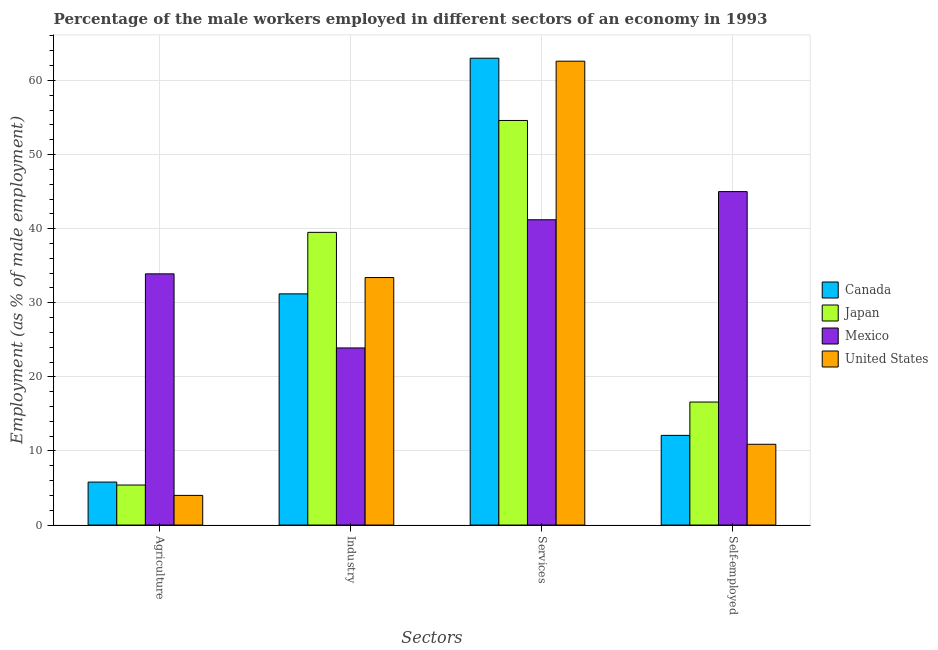How many groups of bars are there?
Ensure brevity in your answer.  4. How many bars are there on the 2nd tick from the right?
Your answer should be compact. 4. What is the label of the 2nd group of bars from the left?
Provide a succinct answer. Industry. What is the percentage of male workers in services in Mexico?
Offer a very short reply. 41.2. Across all countries, what is the maximum percentage of male workers in agriculture?
Offer a terse response. 33.9. Across all countries, what is the minimum percentage of self employed male workers?
Ensure brevity in your answer.  10.9. What is the total percentage of male workers in services in the graph?
Your response must be concise. 221.4. What is the difference between the percentage of male workers in services in Mexico and that in United States?
Make the answer very short. -21.4. What is the difference between the percentage of self employed male workers in Mexico and the percentage of male workers in services in United States?
Offer a terse response. -17.6. What is the average percentage of male workers in services per country?
Your answer should be compact. 55.35. What is the difference between the percentage of male workers in services and percentage of male workers in industry in Japan?
Provide a succinct answer. 15.1. What is the ratio of the percentage of male workers in agriculture in Japan to that in Mexico?
Ensure brevity in your answer.  0.16. What is the difference between the highest and the second highest percentage of male workers in industry?
Ensure brevity in your answer.  6.1. What is the difference between the highest and the lowest percentage of male workers in industry?
Your response must be concise. 15.6. In how many countries, is the percentage of male workers in agriculture greater than the average percentage of male workers in agriculture taken over all countries?
Provide a short and direct response. 1. Is the sum of the percentage of male workers in agriculture in Japan and United States greater than the maximum percentage of self employed male workers across all countries?
Provide a succinct answer. No. What does the 2nd bar from the right in Industry represents?
Offer a terse response. Mexico. Is it the case that in every country, the sum of the percentage of male workers in agriculture and percentage of male workers in industry is greater than the percentage of male workers in services?
Provide a short and direct response. No. What is the difference between two consecutive major ticks on the Y-axis?
Offer a very short reply. 10. Are the values on the major ticks of Y-axis written in scientific E-notation?
Provide a succinct answer. No. How are the legend labels stacked?
Your answer should be very brief. Vertical. What is the title of the graph?
Offer a terse response. Percentage of the male workers employed in different sectors of an economy in 1993. Does "Cyprus" appear as one of the legend labels in the graph?
Your answer should be very brief. No. What is the label or title of the X-axis?
Your response must be concise. Sectors. What is the label or title of the Y-axis?
Offer a terse response. Employment (as % of male employment). What is the Employment (as % of male employment) of Canada in Agriculture?
Provide a short and direct response. 5.8. What is the Employment (as % of male employment) in Japan in Agriculture?
Offer a terse response. 5.4. What is the Employment (as % of male employment) of Mexico in Agriculture?
Make the answer very short. 33.9. What is the Employment (as % of male employment) of Canada in Industry?
Provide a short and direct response. 31.2. What is the Employment (as % of male employment) of Japan in Industry?
Ensure brevity in your answer.  39.5. What is the Employment (as % of male employment) in Mexico in Industry?
Offer a terse response. 23.9. What is the Employment (as % of male employment) in United States in Industry?
Provide a short and direct response. 33.4. What is the Employment (as % of male employment) of Canada in Services?
Ensure brevity in your answer.  63. What is the Employment (as % of male employment) of Japan in Services?
Your answer should be very brief. 54.6. What is the Employment (as % of male employment) of Mexico in Services?
Your response must be concise. 41.2. What is the Employment (as % of male employment) in United States in Services?
Keep it short and to the point. 62.6. What is the Employment (as % of male employment) of Canada in Self-employed?
Keep it short and to the point. 12.1. What is the Employment (as % of male employment) of Japan in Self-employed?
Make the answer very short. 16.6. What is the Employment (as % of male employment) of United States in Self-employed?
Keep it short and to the point. 10.9. Across all Sectors, what is the maximum Employment (as % of male employment) in Canada?
Your response must be concise. 63. Across all Sectors, what is the maximum Employment (as % of male employment) of Japan?
Ensure brevity in your answer.  54.6. Across all Sectors, what is the maximum Employment (as % of male employment) of Mexico?
Provide a short and direct response. 45. Across all Sectors, what is the maximum Employment (as % of male employment) in United States?
Your answer should be very brief. 62.6. Across all Sectors, what is the minimum Employment (as % of male employment) of Canada?
Provide a short and direct response. 5.8. Across all Sectors, what is the minimum Employment (as % of male employment) in Japan?
Offer a terse response. 5.4. Across all Sectors, what is the minimum Employment (as % of male employment) in Mexico?
Your response must be concise. 23.9. What is the total Employment (as % of male employment) in Canada in the graph?
Keep it short and to the point. 112.1. What is the total Employment (as % of male employment) in Japan in the graph?
Provide a succinct answer. 116.1. What is the total Employment (as % of male employment) of Mexico in the graph?
Your response must be concise. 144. What is the total Employment (as % of male employment) of United States in the graph?
Offer a very short reply. 110.9. What is the difference between the Employment (as % of male employment) of Canada in Agriculture and that in Industry?
Ensure brevity in your answer.  -25.4. What is the difference between the Employment (as % of male employment) in Japan in Agriculture and that in Industry?
Keep it short and to the point. -34.1. What is the difference between the Employment (as % of male employment) in Mexico in Agriculture and that in Industry?
Offer a very short reply. 10. What is the difference between the Employment (as % of male employment) in United States in Agriculture and that in Industry?
Ensure brevity in your answer.  -29.4. What is the difference between the Employment (as % of male employment) of Canada in Agriculture and that in Services?
Keep it short and to the point. -57.2. What is the difference between the Employment (as % of male employment) in Japan in Agriculture and that in Services?
Keep it short and to the point. -49.2. What is the difference between the Employment (as % of male employment) of Mexico in Agriculture and that in Services?
Offer a very short reply. -7.3. What is the difference between the Employment (as % of male employment) in United States in Agriculture and that in Services?
Provide a succinct answer. -58.6. What is the difference between the Employment (as % of male employment) of Canada in Agriculture and that in Self-employed?
Your response must be concise. -6.3. What is the difference between the Employment (as % of male employment) in Japan in Agriculture and that in Self-employed?
Provide a succinct answer. -11.2. What is the difference between the Employment (as % of male employment) of United States in Agriculture and that in Self-employed?
Your answer should be very brief. -6.9. What is the difference between the Employment (as % of male employment) in Canada in Industry and that in Services?
Your answer should be very brief. -31.8. What is the difference between the Employment (as % of male employment) of Japan in Industry and that in Services?
Offer a very short reply. -15.1. What is the difference between the Employment (as % of male employment) of Mexico in Industry and that in Services?
Provide a short and direct response. -17.3. What is the difference between the Employment (as % of male employment) of United States in Industry and that in Services?
Your answer should be very brief. -29.2. What is the difference between the Employment (as % of male employment) of Japan in Industry and that in Self-employed?
Offer a terse response. 22.9. What is the difference between the Employment (as % of male employment) in Mexico in Industry and that in Self-employed?
Your response must be concise. -21.1. What is the difference between the Employment (as % of male employment) of United States in Industry and that in Self-employed?
Offer a very short reply. 22.5. What is the difference between the Employment (as % of male employment) in Canada in Services and that in Self-employed?
Provide a short and direct response. 50.9. What is the difference between the Employment (as % of male employment) of Japan in Services and that in Self-employed?
Your response must be concise. 38. What is the difference between the Employment (as % of male employment) of United States in Services and that in Self-employed?
Make the answer very short. 51.7. What is the difference between the Employment (as % of male employment) in Canada in Agriculture and the Employment (as % of male employment) in Japan in Industry?
Ensure brevity in your answer.  -33.7. What is the difference between the Employment (as % of male employment) of Canada in Agriculture and the Employment (as % of male employment) of Mexico in Industry?
Your answer should be very brief. -18.1. What is the difference between the Employment (as % of male employment) in Canada in Agriculture and the Employment (as % of male employment) in United States in Industry?
Your answer should be compact. -27.6. What is the difference between the Employment (as % of male employment) of Japan in Agriculture and the Employment (as % of male employment) of Mexico in Industry?
Keep it short and to the point. -18.5. What is the difference between the Employment (as % of male employment) of Japan in Agriculture and the Employment (as % of male employment) of United States in Industry?
Give a very brief answer. -28. What is the difference between the Employment (as % of male employment) in Canada in Agriculture and the Employment (as % of male employment) in Japan in Services?
Your response must be concise. -48.8. What is the difference between the Employment (as % of male employment) of Canada in Agriculture and the Employment (as % of male employment) of Mexico in Services?
Provide a succinct answer. -35.4. What is the difference between the Employment (as % of male employment) of Canada in Agriculture and the Employment (as % of male employment) of United States in Services?
Your answer should be very brief. -56.8. What is the difference between the Employment (as % of male employment) in Japan in Agriculture and the Employment (as % of male employment) in Mexico in Services?
Provide a succinct answer. -35.8. What is the difference between the Employment (as % of male employment) of Japan in Agriculture and the Employment (as % of male employment) of United States in Services?
Give a very brief answer. -57.2. What is the difference between the Employment (as % of male employment) of Mexico in Agriculture and the Employment (as % of male employment) of United States in Services?
Provide a succinct answer. -28.7. What is the difference between the Employment (as % of male employment) of Canada in Agriculture and the Employment (as % of male employment) of Mexico in Self-employed?
Offer a terse response. -39.2. What is the difference between the Employment (as % of male employment) of Canada in Agriculture and the Employment (as % of male employment) of United States in Self-employed?
Your response must be concise. -5.1. What is the difference between the Employment (as % of male employment) of Japan in Agriculture and the Employment (as % of male employment) of Mexico in Self-employed?
Your answer should be compact. -39.6. What is the difference between the Employment (as % of male employment) of Japan in Agriculture and the Employment (as % of male employment) of United States in Self-employed?
Keep it short and to the point. -5.5. What is the difference between the Employment (as % of male employment) in Canada in Industry and the Employment (as % of male employment) in Japan in Services?
Give a very brief answer. -23.4. What is the difference between the Employment (as % of male employment) of Canada in Industry and the Employment (as % of male employment) of Mexico in Services?
Provide a succinct answer. -10. What is the difference between the Employment (as % of male employment) of Canada in Industry and the Employment (as % of male employment) of United States in Services?
Your answer should be very brief. -31.4. What is the difference between the Employment (as % of male employment) in Japan in Industry and the Employment (as % of male employment) in Mexico in Services?
Your answer should be compact. -1.7. What is the difference between the Employment (as % of male employment) in Japan in Industry and the Employment (as % of male employment) in United States in Services?
Make the answer very short. -23.1. What is the difference between the Employment (as % of male employment) in Mexico in Industry and the Employment (as % of male employment) in United States in Services?
Your response must be concise. -38.7. What is the difference between the Employment (as % of male employment) in Canada in Industry and the Employment (as % of male employment) in Japan in Self-employed?
Ensure brevity in your answer.  14.6. What is the difference between the Employment (as % of male employment) in Canada in Industry and the Employment (as % of male employment) in United States in Self-employed?
Provide a short and direct response. 20.3. What is the difference between the Employment (as % of male employment) of Japan in Industry and the Employment (as % of male employment) of United States in Self-employed?
Provide a short and direct response. 28.6. What is the difference between the Employment (as % of male employment) of Canada in Services and the Employment (as % of male employment) of Japan in Self-employed?
Offer a terse response. 46.4. What is the difference between the Employment (as % of male employment) in Canada in Services and the Employment (as % of male employment) in United States in Self-employed?
Provide a short and direct response. 52.1. What is the difference between the Employment (as % of male employment) in Japan in Services and the Employment (as % of male employment) in United States in Self-employed?
Offer a terse response. 43.7. What is the difference between the Employment (as % of male employment) in Mexico in Services and the Employment (as % of male employment) in United States in Self-employed?
Make the answer very short. 30.3. What is the average Employment (as % of male employment) of Canada per Sectors?
Your answer should be very brief. 28.02. What is the average Employment (as % of male employment) in Japan per Sectors?
Make the answer very short. 29.02. What is the average Employment (as % of male employment) of United States per Sectors?
Ensure brevity in your answer.  27.73. What is the difference between the Employment (as % of male employment) in Canada and Employment (as % of male employment) in Japan in Agriculture?
Your response must be concise. 0.4. What is the difference between the Employment (as % of male employment) of Canada and Employment (as % of male employment) of Mexico in Agriculture?
Make the answer very short. -28.1. What is the difference between the Employment (as % of male employment) of Canada and Employment (as % of male employment) of United States in Agriculture?
Give a very brief answer. 1.8. What is the difference between the Employment (as % of male employment) of Japan and Employment (as % of male employment) of Mexico in Agriculture?
Provide a short and direct response. -28.5. What is the difference between the Employment (as % of male employment) of Mexico and Employment (as % of male employment) of United States in Agriculture?
Keep it short and to the point. 29.9. What is the difference between the Employment (as % of male employment) of Canada and Employment (as % of male employment) of Japan in Industry?
Your answer should be compact. -8.3. What is the difference between the Employment (as % of male employment) in Canada and Employment (as % of male employment) in Mexico in Industry?
Offer a very short reply. 7.3. What is the difference between the Employment (as % of male employment) in Canada and Employment (as % of male employment) in United States in Industry?
Offer a terse response. -2.2. What is the difference between the Employment (as % of male employment) in Japan and Employment (as % of male employment) in Mexico in Industry?
Make the answer very short. 15.6. What is the difference between the Employment (as % of male employment) in Canada and Employment (as % of male employment) in Japan in Services?
Offer a terse response. 8.4. What is the difference between the Employment (as % of male employment) of Canada and Employment (as % of male employment) of Mexico in Services?
Offer a very short reply. 21.8. What is the difference between the Employment (as % of male employment) of Canada and Employment (as % of male employment) of United States in Services?
Ensure brevity in your answer.  0.4. What is the difference between the Employment (as % of male employment) of Mexico and Employment (as % of male employment) of United States in Services?
Keep it short and to the point. -21.4. What is the difference between the Employment (as % of male employment) in Canada and Employment (as % of male employment) in Mexico in Self-employed?
Give a very brief answer. -32.9. What is the difference between the Employment (as % of male employment) in Canada and Employment (as % of male employment) in United States in Self-employed?
Provide a short and direct response. 1.2. What is the difference between the Employment (as % of male employment) of Japan and Employment (as % of male employment) of Mexico in Self-employed?
Your answer should be very brief. -28.4. What is the difference between the Employment (as % of male employment) of Mexico and Employment (as % of male employment) of United States in Self-employed?
Ensure brevity in your answer.  34.1. What is the ratio of the Employment (as % of male employment) of Canada in Agriculture to that in Industry?
Offer a very short reply. 0.19. What is the ratio of the Employment (as % of male employment) in Japan in Agriculture to that in Industry?
Give a very brief answer. 0.14. What is the ratio of the Employment (as % of male employment) of Mexico in Agriculture to that in Industry?
Provide a succinct answer. 1.42. What is the ratio of the Employment (as % of male employment) of United States in Agriculture to that in Industry?
Provide a short and direct response. 0.12. What is the ratio of the Employment (as % of male employment) in Canada in Agriculture to that in Services?
Make the answer very short. 0.09. What is the ratio of the Employment (as % of male employment) of Japan in Agriculture to that in Services?
Make the answer very short. 0.1. What is the ratio of the Employment (as % of male employment) in Mexico in Agriculture to that in Services?
Provide a succinct answer. 0.82. What is the ratio of the Employment (as % of male employment) in United States in Agriculture to that in Services?
Keep it short and to the point. 0.06. What is the ratio of the Employment (as % of male employment) of Canada in Agriculture to that in Self-employed?
Your response must be concise. 0.48. What is the ratio of the Employment (as % of male employment) in Japan in Agriculture to that in Self-employed?
Your response must be concise. 0.33. What is the ratio of the Employment (as % of male employment) in Mexico in Agriculture to that in Self-employed?
Offer a very short reply. 0.75. What is the ratio of the Employment (as % of male employment) in United States in Agriculture to that in Self-employed?
Your response must be concise. 0.37. What is the ratio of the Employment (as % of male employment) in Canada in Industry to that in Services?
Give a very brief answer. 0.5. What is the ratio of the Employment (as % of male employment) in Japan in Industry to that in Services?
Offer a terse response. 0.72. What is the ratio of the Employment (as % of male employment) in Mexico in Industry to that in Services?
Keep it short and to the point. 0.58. What is the ratio of the Employment (as % of male employment) in United States in Industry to that in Services?
Offer a terse response. 0.53. What is the ratio of the Employment (as % of male employment) of Canada in Industry to that in Self-employed?
Make the answer very short. 2.58. What is the ratio of the Employment (as % of male employment) of Japan in Industry to that in Self-employed?
Give a very brief answer. 2.38. What is the ratio of the Employment (as % of male employment) in Mexico in Industry to that in Self-employed?
Provide a succinct answer. 0.53. What is the ratio of the Employment (as % of male employment) in United States in Industry to that in Self-employed?
Keep it short and to the point. 3.06. What is the ratio of the Employment (as % of male employment) of Canada in Services to that in Self-employed?
Give a very brief answer. 5.21. What is the ratio of the Employment (as % of male employment) of Japan in Services to that in Self-employed?
Your answer should be compact. 3.29. What is the ratio of the Employment (as % of male employment) in Mexico in Services to that in Self-employed?
Offer a terse response. 0.92. What is the ratio of the Employment (as % of male employment) in United States in Services to that in Self-employed?
Provide a short and direct response. 5.74. What is the difference between the highest and the second highest Employment (as % of male employment) of Canada?
Your answer should be compact. 31.8. What is the difference between the highest and the second highest Employment (as % of male employment) in Japan?
Your answer should be very brief. 15.1. What is the difference between the highest and the second highest Employment (as % of male employment) of Mexico?
Keep it short and to the point. 3.8. What is the difference between the highest and the second highest Employment (as % of male employment) in United States?
Provide a short and direct response. 29.2. What is the difference between the highest and the lowest Employment (as % of male employment) in Canada?
Offer a very short reply. 57.2. What is the difference between the highest and the lowest Employment (as % of male employment) in Japan?
Give a very brief answer. 49.2. What is the difference between the highest and the lowest Employment (as % of male employment) in Mexico?
Provide a succinct answer. 21.1. What is the difference between the highest and the lowest Employment (as % of male employment) of United States?
Give a very brief answer. 58.6. 